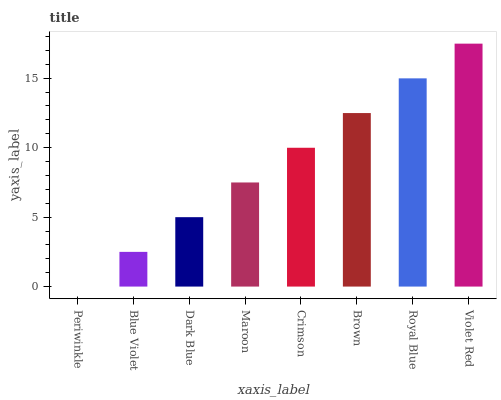Is Periwinkle the minimum?
Answer yes or no. Yes. Is Violet Red the maximum?
Answer yes or no. Yes. Is Blue Violet the minimum?
Answer yes or no. No. Is Blue Violet the maximum?
Answer yes or no. No. Is Blue Violet greater than Periwinkle?
Answer yes or no. Yes. Is Periwinkle less than Blue Violet?
Answer yes or no. Yes. Is Periwinkle greater than Blue Violet?
Answer yes or no. No. Is Blue Violet less than Periwinkle?
Answer yes or no. No. Is Crimson the high median?
Answer yes or no. Yes. Is Maroon the low median?
Answer yes or no. Yes. Is Royal Blue the high median?
Answer yes or no. No. Is Brown the low median?
Answer yes or no. No. 